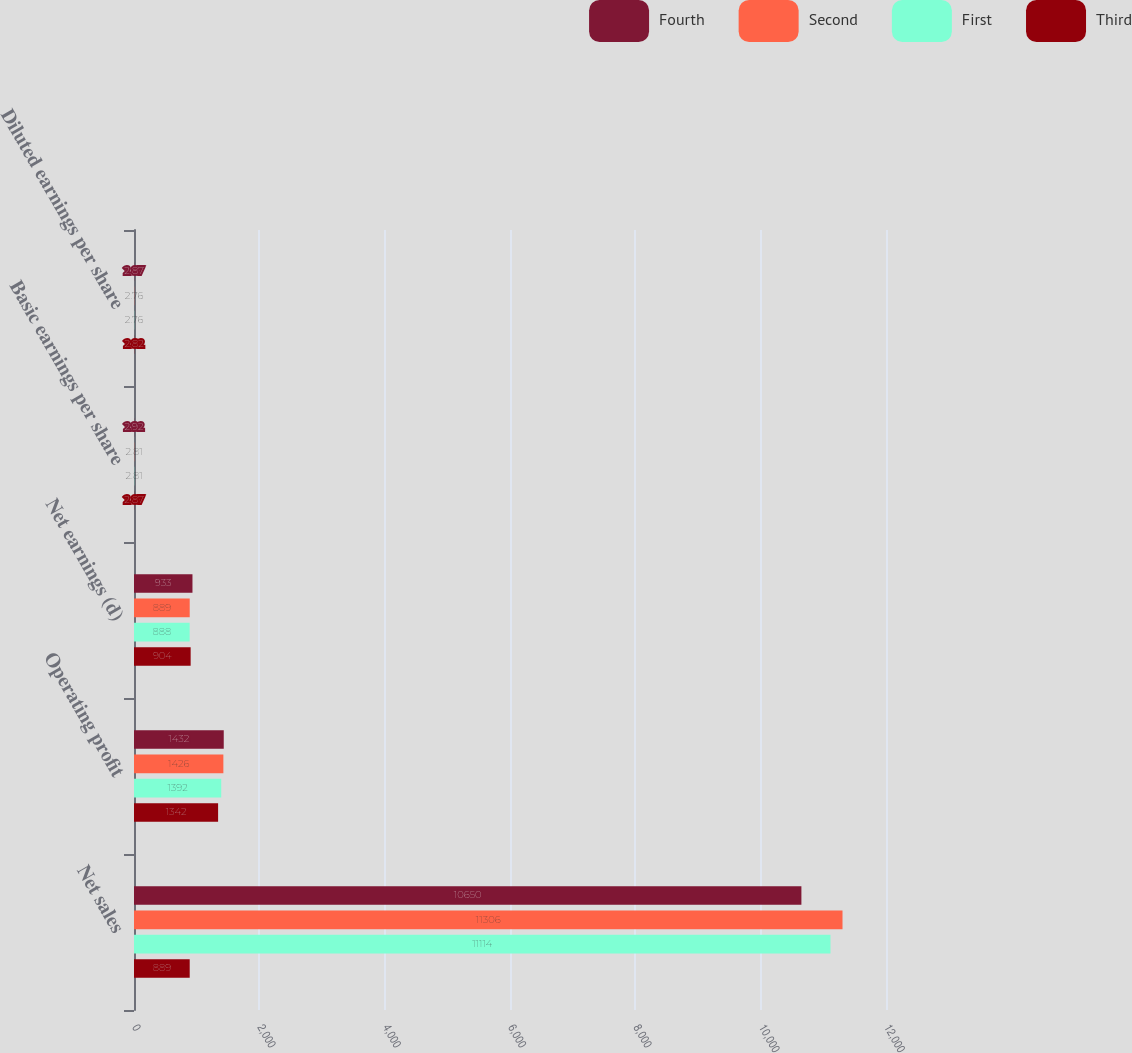Convert chart. <chart><loc_0><loc_0><loc_500><loc_500><stacked_bar_chart><ecel><fcel>Net sales<fcel>Operating profit<fcel>Net earnings (d)<fcel>Basic earnings per share<fcel>Diluted earnings per share<nl><fcel>Fourth<fcel>10650<fcel>1432<fcel>933<fcel>2.92<fcel>2.87<nl><fcel>Second<fcel>11306<fcel>1426<fcel>889<fcel>2.81<fcel>2.76<nl><fcel>First<fcel>11114<fcel>1392<fcel>888<fcel>2.81<fcel>2.76<nl><fcel>Third<fcel>889<fcel>1342<fcel>904<fcel>2.87<fcel>2.82<nl></chart> 